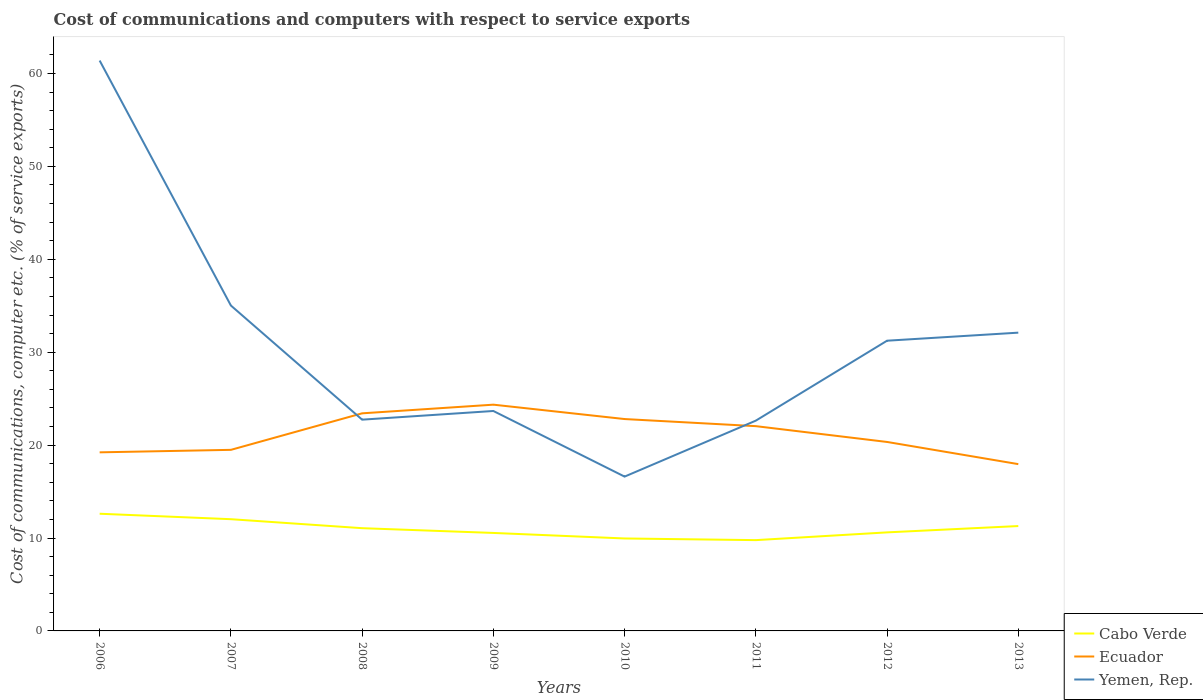Is the number of lines equal to the number of legend labels?
Your answer should be compact. Yes. Across all years, what is the maximum cost of communications and computers in Yemen, Rep.?
Offer a very short reply. 16.61. In which year was the cost of communications and computers in Ecuador maximum?
Offer a very short reply. 2013. What is the total cost of communications and computers in Yemen, Rep. in the graph?
Your answer should be very brief. 38.75. What is the difference between the highest and the second highest cost of communications and computers in Ecuador?
Offer a very short reply. 6.4. What is the difference between the highest and the lowest cost of communications and computers in Cabo Verde?
Provide a short and direct response. 4. How many lines are there?
Offer a very short reply. 3. What is the difference between two consecutive major ticks on the Y-axis?
Ensure brevity in your answer.  10. Are the values on the major ticks of Y-axis written in scientific E-notation?
Provide a short and direct response. No. Does the graph contain any zero values?
Offer a very short reply. No. Where does the legend appear in the graph?
Ensure brevity in your answer.  Bottom right. What is the title of the graph?
Give a very brief answer. Cost of communications and computers with respect to service exports. What is the label or title of the X-axis?
Provide a succinct answer. Years. What is the label or title of the Y-axis?
Your answer should be very brief. Cost of communications, computer etc. (% of service exports). What is the Cost of communications, computer etc. (% of service exports) in Cabo Verde in 2006?
Provide a succinct answer. 12.61. What is the Cost of communications, computer etc. (% of service exports) in Ecuador in 2006?
Give a very brief answer. 19.22. What is the Cost of communications, computer etc. (% of service exports) in Yemen, Rep. in 2006?
Your answer should be compact. 61.39. What is the Cost of communications, computer etc. (% of service exports) in Cabo Verde in 2007?
Provide a short and direct response. 12.02. What is the Cost of communications, computer etc. (% of service exports) of Ecuador in 2007?
Offer a very short reply. 19.49. What is the Cost of communications, computer etc. (% of service exports) in Yemen, Rep. in 2007?
Provide a succinct answer. 35.02. What is the Cost of communications, computer etc. (% of service exports) in Cabo Verde in 2008?
Your answer should be compact. 11.06. What is the Cost of communications, computer etc. (% of service exports) of Ecuador in 2008?
Your response must be concise. 23.42. What is the Cost of communications, computer etc. (% of service exports) of Yemen, Rep. in 2008?
Offer a terse response. 22.74. What is the Cost of communications, computer etc. (% of service exports) of Cabo Verde in 2009?
Ensure brevity in your answer.  10.55. What is the Cost of communications, computer etc. (% of service exports) of Ecuador in 2009?
Provide a succinct answer. 24.35. What is the Cost of communications, computer etc. (% of service exports) of Yemen, Rep. in 2009?
Offer a very short reply. 23.67. What is the Cost of communications, computer etc. (% of service exports) in Cabo Verde in 2010?
Keep it short and to the point. 9.95. What is the Cost of communications, computer etc. (% of service exports) in Ecuador in 2010?
Provide a succinct answer. 22.8. What is the Cost of communications, computer etc. (% of service exports) in Yemen, Rep. in 2010?
Offer a terse response. 16.61. What is the Cost of communications, computer etc. (% of service exports) in Cabo Verde in 2011?
Your answer should be compact. 9.77. What is the Cost of communications, computer etc. (% of service exports) of Ecuador in 2011?
Make the answer very short. 22.04. What is the Cost of communications, computer etc. (% of service exports) in Yemen, Rep. in 2011?
Your response must be concise. 22.63. What is the Cost of communications, computer etc. (% of service exports) in Cabo Verde in 2012?
Your answer should be very brief. 10.61. What is the Cost of communications, computer etc. (% of service exports) in Ecuador in 2012?
Give a very brief answer. 20.34. What is the Cost of communications, computer etc. (% of service exports) of Yemen, Rep. in 2012?
Give a very brief answer. 31.24. What is the Cost of communications, computer etc. (% of service exports) of Cabo Verde in 2013?
Your answer should be compact. 11.29. What is the Cost of communications, computer etc. (% of service exports) in Ecuador in 2013?
Keep it short and to the point. 17.95. What is the Cost of communications, computer etc. (% of service exports) in Yemen, Rep. in 2013?
Ensure brevity in your answer.  32.1. Across all years, what is the maximum Cost of communications, computer etc. (% of service exports) in Cabo Verde?
Ensure brevity in your answer.  12.61. Across all years, what is the maximum Cost of communications, computer etc. (% of service exports) of Ecuador?
Keep it short and to the point. 24.35. Across all years, what is the maximum Cost of communications, computer etc. (% of service exports) of Yemen, Rep.?
Offer a very short reply. 61.39. Across all years, what is the minimum Cost of communications, computer etc. (% of service exports) in Cabo Verde?
Your response must be concise. 9.77. Across all years, what is the minimum Cost of communications, computer etc. (% of service exports) of Ecuador?
Offer a very short reply. 17.95. Across all years, what is the minimum Cost of communications, computer etc. (% of service exports) in Yemen, Rep.?
Give a very brief answer. 16.61. What is the total Cost of communications, computer etc. (% of service exports) in Cabo Verde in the graph?
Your answer should be very brief. 87.86. What is the total Cost of communications, computer etc. (% of service exports) in Ecuador in the graph?
Give a very brief answer. 169.61. What is the total Cost of communications, computer etc. (% of service exports) in Yemen, Rep. in the graph?
Offer a terse response. 245.4. What is the difference between the Cost of communications, computer etc. (% of service exports) in Cabo Verde in 2006 and that in 2007?
Make the answer very short. 0.59. What is the difference between the Cost of communications, computer etc. (% of service exports) in Ecuador in 2006 and that in 2007?
Ensure brevity in your answer.  -0.27. What is the difference between the Cost of communications, computer etc. (% of service exports) in Yemen, Rep. in 2006 and that in 2007?
Keep it short and to the point. 26.37. What is the difference between the Cost of communications, computer etc. (% of service exports) of Cabo Verde in 2006 and that in 2008?
Ensure brevity in your answer.  1.55. What is the difference between the Cost of communications, computer etc. (% of service exports) in Ecuador in 2006 and that in 2008?
Provide a succinct answer. -4.2. What is the difference between the Cost of communications, computer etc. (% of service exports) in Yemen, Rep. in 2006 and that in 2008?
Make the answer very short. 38.65. What is the difference between the Cost of communications, computer etc. (% of service exports) of Cabo Verde in 2006 and that in 2009?
Your answer should be compact. 2.07. What is the difference between the Cost of communications, computer etc. (% of service exports) in Ecuador in 2006 and that in 2009?
Your answer should be compact. -5.13. What is the difference between the Cost of communications, computer etc. (% of service exports) in Yemen, Rep. in 2006 and that in 2009?
Your answer should be compact. 37.72. What is the difference between the Cost of communications, computer etc. (% of service exports) of Cabo Verde in 2006 and that in 2010?
Your answer should be compact. 2.66. What is the difference between the Cost of communications, computer etc. (% of service exports) of Ecuador in 2006 and that in 2010?
Your answer should be very brief. -3.58. What is the difference between the Cost of communications, computer etc. (% of service exports) in Yemen, Rep. in 2006 and that in 2010?
Give a very brief answer. 44.78. What is the difference between the Cost of communications, computer etc. (% of service exports) of Cabo Verde in 2006 and that in 2011?
Provide a succinct answer. 2.84. What is the difference between the Cost of communications, computer etc. (% of service exports) of Ecuador in 2006 and that in 2011?
Your answer should be very brief. -2.82. What is the difference between the Cost of communications, computer etc. (% of service exports) in Yemen, Rep. in 2006 and that in 2011?
Ensure brevity in your answer.  38.75. What is the difference between the Cost of communications, computer etc. (% of service exports) of Cabo Verde in 2006 and that in 2012?
Provide a succinct answer. 2.01. What is the difference between the Cost of communications, computer etc. (% of service exports) of Ecuador in 2006 and that in 2012?
Ensure brevity in your answer.  -1.12. What is the difference between the Cost of communications, computer etc. (% of service exports) in Yemen, Rep. in 2006 and that in 2012?
Keep it short and to the point. 30.15. What is the difference between the Cost of communications, computer etc. (% of service exports) of Cabo Verde in 2006 and that in 2013?
Offer a very short reply. 1.33. What is the difference between the Cost of communications, computer etc. (% of service exports) in Ecuador in 2006 and that in 2013?
Give a very brief answer. 1.27. What is the difference between the Cost of communications, computer etc. (% of service exports) of Yemen, Rep. in 2006 and that in 2013?
Offer a very short reply. 29.29. What is the difference between the Cost of communications, computer etc. (% of service exports) of Cabo Verde in 2007 and that in 2008?
Your response must be concise. 0.97. What is the difference between the Cost of communications, computer etc. (% of service exports) of Ecuador in 2007 and that in 2008?
Your answer should be very brief. -3.93. What is the difference between the Cost of communications, computer etc. (% of service exports) in Yemen, Rep. in 2007 and that in 2008?
Offer a very short reply. 12.28. What is the difference between the Cost of communications, computer etc. (% of service exports) of Cabo Verde in 2007 and that in 2009?
Give a very brief answer. 1.48. What is the difference between the Cost of communications, computer etc. (% of service exports) of Ecuador in 2007 and that in 2009?
Make the answer very short. -4.86. What is the difference between the Cost of communications, computer etc. (% of service exports) of Yemen, Rep. in 2007 and that in 2009?
Ensure brevity in your answer.  11.35. What is the difference between the Cost of communications, computer etc. (% of service exports) in Cabo Verde in 2007 and that in 2010?
Provide a short and direct response. 2.07. What is the difference between the Cost of communications, computer etc. (% of service exports) in Ecuador in 2007 and that in 2010?
Ensure brevity in your answer.  -3.32. What is the difference between the Cost of communications, computer etc. (% of service exports) of Yemen, Rep. in 2007 and that in 2010?
Ensure brevity in your answer.  18.41. What is the difference between the Cost of communications, computer etc. (% of service exports) of Cabo Verde in 2007 and that in 2011?
Your answer should be very brief. 2.25. What is the difference between the Cost of communications, computer etc. (% of service exports) of Ecuador in 2007 and that in 2011?
Keep it short and to the point. -2.55. What is the difference between the Cost of communications, computer etc. (% of service exports) in Yemen, Rep. in 2007 and that in 2011?
Make the answer very short. 12.39. What is the difference between the Cost of communications, computer etc. (% of service exports) in Cabo Verde in 2007 and that in 2012?
Ensure brevity in your answer.  1.42. What is the difference between the Cost of communications, computer etc. (% of service exports) of Ecuador in 2007 and that in 2012?
Make the answer very short. -0.85. What is the difference between the Cost of communications, computer etc. (% of service exports) in Yemen, Rep. in 2007 and that in 2012?
Provide a succinct answer. 3.79. What is the difference between the Cost of communications, computer etc. (% of service exports) in Cabo Verde in 2007 and that in 2013?
Provide a succinct answer. 0.74. What is the difference between the Cost of communications, computer etc. (% of service exports) of Ecuador in 2007 and that in 2013?
Your answer should be very brief. 1.54. What is the difference between the Cost of communications, computer etc. (% of service exports) in Yemen, Rep. in 2007 and that in 2013?
Keep it short and to the point. 2.92. What is the difference between the Cost of communications, computer etc. (% of service exports) of Cabo Verde in 2008 and that in 2009?
Offer a very short reply. 0.51. What is the difference between the Cost of communications, computer etc. (% of service exports) in Ecuador in 2008 and that in 2009?
Offer a terse response. -0.93. What is the difference between the Cost of communications, computer etc. (% of service exports) of Yemen, Rep. in 2008 and that in 2009?
Offer a very short reply. -0.93. What is the difference between the Cost of communications, computer etc. (% of service exports) of Cabo Verde in 2008 and that in 2010?
Keep it short and to the point. 1.11. What is the difference between the Cost of communications, computer etc. (% of service exports) of Ecuador in 2008 and that in 2010?
Your response must be concise. 0.62. What is the difference between the Cost of communications, computer etc. (% of service exports) in Yemen, Rep. in 2008 and that in 2010?
Offer a terse response. 6.13. What is the difference between the Cost of communications, computer etc. (% of service exports) in Cabo Verde in 2008 and that in 2011?
Ensure brevity in your answer.  1.29. What is the difference between the Cost of communications, computer etc. (% of service exports) of Ecuador in 2008 and that in 2011?
Give a very brief answer. 1.38. What is the difference between the Cost of communications, computer etc. (% of service exports) of Yemen, Rep. in 2008 and that in 2011?
Your answer should be very brief. 0.11. What is the difference between the Cost of communications, computer etc. (% of service exports) of Cabo Verde in 2008 and that in 2012?
Your answer should be compact. 0.45. What is the difference between the Cost of communications, computer etc. (% of service exports) of Ecuador in 2008 and that in 2012?
Give a very brief answer. 3.08. What is the difference between the Cost of communications, computer etc. (% of service exports) of Yemen, Rep. in 2008 and that in 2012?
Make the answer very short. -8.5. What is the difference between the Cost of communications, computer etc. (% of service exports) in Cabo Verde in 2008 and that in 2013?
Keep it short and to the point. -0.23. What is the difference between the Cost of communications, computer etc. (% of service exports) of Ecuador in 2008 and that in 2013?
Offer a terse response. 5.47. What is the difference between the Cost of communications, computer etc. (% of service exports) of Yemen, Rep. in 2008 and that in 2013?
Provide a short and direct response. -9.36. What is the difference between the Cost of communications, computer etc. (% of service exports) of Cabo Verde in 2009 and that in 2010?
Offer a terse response. 0.6. What is the difference between the Cost of communications, computer etc. (% of service exports) of Ecuador in 2009 and that in 2010?
Keep it short and to the point. 1.55. What is the difference between the Cost of communications, computer etc. (% of service exports) of Yemen, Rep. in 2009 and that in 2010?
Ensure brevity in your answer.  7.06. What is the difference between the Cost of communications, computer etc. (% of service exports) in Cabo Verde in 2009 and that in 2011?
Offer a terse response. 0.77. What is the difference between the Cost of communications, computer etc. (% of service exports) of Ecuador in 2009 and that in 2011?
Your answer should be very brief. 2.31. What is the difference between the Cost of communications, computer etc. (% of service exports) in Yemen, Rep. in 2009 and that in 2011?
Your answer should be very brief. 1.04. What is the difference between the Cost of communications, computer etc. (% of service exports) of Cabo Verde in 2009 and that in 2012?
Make the answer very short. -0.06. What is the difference between the Cost of communications, computer etc. (% of service exports) of Ecuador in 2009 and that in 2012?
Your response must be concise. 4.01. What is the difference between the Cost of communications, computer etc. (% of service exports) of Yemen, Rep. in 2009 and that in 2012?
Make the answer very short. -7.56. What is the difference between the Cost of communications, computer etc. (% of service exports) in Cabo Verde in 2009 and that in 2013?
Give a very brief answer. -0.74. What is the difference between the Cost of communications, computer etc. (% of service exports) of Ecuador in 2009 and that in 2013?
Your response must be concise. 6.4. What is the difference between the Cost of communications, computer etc. (% of service exports) in Yemen, Rep. in 2009 and that in 2013?
Provide a succinct answer. -8.43. What is the difference between the Cost of communications, computer etc. (% of service exports) of Cabo Verde in 2010 and that in 2011?
Give a very brief answer. 0.18. What is the difference between the Cost of communications, computer etc. (% of service exports) in Ecuador in 2010 and that in 2011?
Your response must be concise. 0.77. What is the difference between the Cost of communications, computer etc. (% of service exports) in Yemen, Rep. in 2010 and that in 2011?
Give a very brief answer. -6.02. What is the difference between the Cost of communications, computer etc. (% of service exports) in Cabo Verde in 2010 and that in 2012?
Offer a very short reply. -0.66. What is the difference between the Cost of communications, computer etc. (% of service exports) of Ecuador in 2010 and that in 2012?
Give a very brief answer. 2.47. What is the difference between the Cost of communications, computer etc. (% of service exports) of Yemen, Rep. in 2010 and that in 2012?
Your answer should be compact. -14.63. What is the difference between the Cost of communications, computer etc. (% of service exports) in Cabo Verde in 2010 and that in 2013?
Offer a very short reply. -1.34. What is the difference between the Cost of communications, computer etc. (% of service exports) of Ecuador in 2010 and that in 2013?
Your answer should be compact. 4.85. What is the difference between the Cost of communications, computer etc. (% of service exports) in Yemen, Rep. in 2010 and that in 2013?
Provide a succinct answer. -15.49. What is the difference between the Cost of communications, computer etc. (% of service exports) of Cabo Verde in 2011 and that in 2012?
Your answer should be compact. -0.83. What is the difference between the Cost of communications, computer etc. (% of service exports) of Ecuador in 2011 and that in 2012?
Offer a very short reply. 1.7. What is the difference between the Cost of communications, computer etc. (% of service exports) in Yemen, Rep. in 2011 and that in 2012?
Your answer should be very brief. -8.6. What is the difference between the Cost of communications, computer etc. (% of service exports) in Cabo Verde in 2011 and that in 2013?
Make the answer very short. -1.52. What is the difference between the Cost of communications, computer etc. (% of service exports) of Ecuador in 2011 and that in 2013?
Make the answer very short. 4.09. What is the difference between the Cost of communications, computer etc. (% of service exports) in Yemen, Rep. in 2011 and that in 2013?
Give a very brief answer. -9.47. What is the difference between the Cost of communications, computer etc. (% of service exports) of Cabo Verde in 2012 and that in 2013?
Provide a short and direct response. -0.68. What is the difference between the Cost of communications, computer etc. (% of service exports) in Ecuador in 2012 and that in 2013?
Give a very brief answer. 2.39. What is the difference between the Cost of communications, computer etc. (% of service exports) in Yemen, Rep. in 2012 and that in 2013?
Offer a very short reply. -0.87. What is the difference between the Cost of communications, computer etc. (% of service exports) of Cabo Verde in 2006 and the Cost of communications, computer etc. (% of service exports) of Ecuador in 2007?
Provide a succinct answer. -6.88. What is the difference between the Cost of communications, computer etc. (% of service exports) of Cabo Verde in 2006 and the Cost of communications, computer etc. (% of service exports) of Yemen, Rep. in 2007?
Offer a terse response. -22.41. What is the difference between the Cost of communications, computer etc. (% of service exports) in Ecuador in 2006 and the Cost of communications, computer etc. (% of service exports) in Yemen, Rep. in 2007?
Your answer should be compact. -15.8. What is the difference between the Cost of communications, computer etc. (% of service exports) in Cabo Verde in 2006 and the Cost of communications, computer etc. (% of service exports) in Ecuador in 2008?
Offer a very short reply. -10.81. What is the difference between the Cost of communications, computer etc. (% of service exports) in Cabo Verde in 2006 and the Cost of communications, computer etc. (% of service exports) in Yemen, Rep. in 2008?
Your answer should be compact. -10.13. What is the difference between the Cost of communications, computer etc. (% of service exports) of Ecuador in 2006 and the Cost of communications, computer etc. (% of service exports) of Yemen, Rep. in 2008?
Give a very brief answer. -3.52. What is the difference between the Cost of communications, computer etc. (% of service exports) in Cabo Verde in 2006 and the Cost of communications, computer etc. (% of service exports) in Ecuador in 2009?
Offer a terse response. -11.74. What is the difference between the Cost of communications, computer etc. (% of service exports) of Cabo Verde in 2006 and the Cost of communications, computer etc. (% of service exports) of Yemen, Rep. in 2009?
Your answer should be very brief. -11.06. What is the difference between the Cost of communications, computer etc. (% of service exports) in Ecuador in 2006 and the Cost of communications, computer etc. (% of service exports) in Yemen, Rep. in 2009?
Ensure brevity in your answer.  -4.45. What is the difference between the Cost of communications, computer etc. (% of service exports) in Cabo Verde in 2006 and the Cost of communications, computer etc. (% of service exports) in Ecuador in 2010?
Provide a short and direct response. -10.19. What is the difference between the Cost of communications, computer etc. (% of service exports) in Cabo Verde in 2006 and the Cost of communications, computer etc. (% of service exports) in Yemen, Rep. in 2010?
Your response must be concise. -4. What is the difference between the Cost of communications, computer etc. (% of service exports) of Ecuador in 2006 and the Cost of communications, computer etc. (% of service exports) of Yemen, Rep. in 2010?
Keep it short and to the point. 2.61. What is the difference between the Cost of communications, computer etc. (% of service exports) of Cabo Verde in 2006 and the Cost of communications, computer etc. (% of service exports) of Ecuador in 2011?
Offer a very short reply. -9.43. What is the difference between the Cost of communications, computer etc. (% of service exports) in Cabo Verde in 2006 and the Cost of communications, computer etc. (% of service exports) in Yemen, Rep. in 2011?
Your response must be concise. -10.02. What is the difference between the Cost of communications, computer etc. (% of service exports) in Ecuador in 2006 and the Cost of communications, computer etc. (% of service exports) in Yemen, Rep. in 2011?
Give a very brief answer. -3.41. What is the difference between the Cost of communications, computer etc. (% of service exports) of Cabo Verde in 2006 and the Cost of communications, computer etc. (% of service exports) of Ecuador in 2012?
Your answer should be very brief. -7.73. What is the difference between the Cost of communications, computer etc. (% of service exports) of Cabo Verde in 2006 and the Cost of communications, computer etc. (% of service exports) of Yemen, Rep. in 2012?
Keep it short and to the point. -18.62. What is the difference between the Cost of communications, computer etc. (% of service exports) of Ecuador in 2006 and the Cost of communications, computer etc. (% of service exports) of Yemen, Rep. in 2012?
Your answer should be compact. -12.02. What is the difference between the Cost of communications, computer etc. (% of service exports) of Cabo Verde in 2006 and the Cost of communications, computer etc. (% of service exports) of Ecuador in 2013?
Your answer should be very brief. -5.34. What is the difference between the Cost of communications, computer etc. (% of service exports) in Cabo Verde in 2006 and the Cost of communications, computer etc. (% of service exports) in Yemen, Rep. in 2013?
Your answer should be very brief. -19.49. What is the difference between the Cost of communications, computer etc. (% of service exports) of Ecuador in 2006 and the Cost of communications, computer etc. (% of service exports) of Yemen, Rep. in 2013?
Your answer should be very brief. -12.88. What is the difference between the Cost of communications, computer etc. (% of service exports) of Cabo Verde in 2007 and the Cost of communications, computer etc. (% of service exports) of Ecuador in 2008?
Offer a terse response. -11.39. What is the difference between the Cost of communications, computer etc. (% of service exports) of Cabo Verde in 2007 and the Cost of communications, computer etc. (% of service exports) of Yemen, Rep. in 2008?
Your answer should be compact. -10.71. What is the difference between the Cost of communications, computer etc. (% of service exports) of Ecuador in 2007 and the Cost of communications, computer etc. (% of service exports) of Yemen, Rep. in 2008?
Provide a succinct answer. -3.25. What is the difference between the Cost of communications, computer etc. (% of service exports) in Cabo Verde in 2007 and the Cost of communications, computer etc. (% of service exports) in Ecuador in 2009?
Provide a short and direct response. -12.33. What is the difference between the Cost of communications, computer etc. (% of service exports) of Cabo Verde in 2007 and the Cost of communications, computer etc. (% of service exports) of Yemen, Rep. in 2009?
Your response must be concise. -11.65. What is the difference between the Cost of communications, computer etc. (% of service exports) of Ecuador in 2007 and the Cost of communications, computer etc. (% of service exports) of Yemen, Rep. in 2009?
Make the answer very short. -4.18. What is the difference between the Cost of communications, computer etc. (% of service exports) in Cabo Verde in 2007 and the Cost of communications, computer etc. (% of service exports) in Ecuador in 2010?
Ensure brevity in your answer.  -10.78. What is the difference between the Cost of communications, computer etc. (% of service exports) in Cabo Verde in 2007 and the Cost of communications, computer etc. (% of service exports) in Yemen, Rep. in 2010?
Your response must be concise. -4.58. What is the difference between the Cost of communications, computer etc. (% of service exports) in Ecuador in 2007 and the Cost of communications, computer etc. (% of service exports) in Yemen, Rep. in 2010?
Keep it short and to the point. 2.88. What is the difference between the Cost of communications, computer etc. (% of service exports) of Cabo Verde in 2007 and the Cost of communications, computer etc. (% of service exports) of Ecuador in 2011?
Keep it short and to the point. -10.01. What is the difference between the Cost of communications, computer etc. (% of service exports) in Cabo Verde in 2007 and the Cost of communications, computer etc. (% of service exports) in Yemen, Rep. in 2011?
Provide a succinct answer. -10.61. What is the difference between the Cost of communications, computer etc. (% of service exports) of Ecuador in 2007 and the Cost of communications, computer etc. (% of service exports) of Yemen, Rep. in 2011?
Offer a very short reply. -3.14. What is the difference between the Cost of communications, computer etc. (% of service exports) of Cabo Verde in 2007 and the Cost of communications, computer etc. (% of service exports) of Ecuador in 2012?
Ensure brevity in your answer.  -8.31. What is the difference between the Cost of communications, computer etc. (% of service exports) in Cabo Verde in 2007 and the Cost of communications, computer etc. (% of service exports) in Yemen, Rep. in 2012?
Make the answer very short. -19.21. What is the difference between the Cost of communications, computer etc. (% of service exports) in Ecuador in 2007 and the Cost of communications, computer etc. (% of service exports) in Yemen, Rep. in 2012?
Give a very brief answer. -11.75. What is the difference between the Cost of communications, computer etc. (% of service exports) in Cabo Verde in 2007 and the Cost of communications, computer etc. (% of service exports) in Ecuador in 2013?
Your response must be concise. -5.93. What is the difference between the Cost of communications, computer etc. (% of service exports) of Cabo Verde in 2007 and the Cost of communications, computer etc. (% of service exports) of Yemen, Rep. in 2013?
Make the answer very short. -20.08. What is the difference between the Cost of communications, computer etc. (% of service exports) in Ecuador in 2007 and the Cost of communications, computer etc. (% of service exports) in Yemen, Rep. in 2013?
Keep it short and to the point. -12.61. What is the difference between the Cost of communications, computer etc. (% of service exports) of Cabo Verde in 2008 and the Cost of communications, computer etc. (% of service exports) of Ecuador in 2009?
Your answer should be compact. -13.29. What is the difference between the Cost of communications, computer etc. (% of service exports) of Cabo Verde in 2008 and the Cost of communications, computer etc. (% of service exports) of Yemen, Rep. in 2009?
Keep it short and to the point. -12.61. What is the difference between the Cost of communications, computer etc. (% of service exports) in Ecuador in 2008 and the Cost of communications, computer etc. (% of service exports) in Yemen, Rep. in 2009?
Give a very brief answer. -0.25. What is the difference between the Cost of communications, computer etc. (% of service exports) in Cabo Verde in 2008 and the Cost of communications, computer etc. (% of service exports) in Ecuador in 2010?
Your answer should be compact. -11.75. What is the difference between the Cost of communications, computer etc. (% of service exports) of Cabo Verde in 2008 and the Cost of communications, computer etc. (% of service exports) of Yemen, Rep. in 2010?
Offer a terse response. -5.55. What is the difference between the Cost of communications, computer etc. (% of service exports) of Ecuador in 2008 and the Cost of communications, computer etc. (% of service exports) of Yemen, Rep. in 2010?
Ensure brevity in your answer.  6.81. What is the difference between the Cost of communications, computer etc. (% of service exports) in Cabo Verde in 2008 and the Cost of communications, computer etc. (% of service exports) in Ecuador in 2011?
Your response must be concise. -10.98. What is the difference between the Cost of communications, computer etc. (% of service exports) in Cabo Verde in 2008 and the Cost of communications, computer etc. (% of service exports) in Yemen, Rep. in 2011?
Provide a succinct answer. -11.57. What is the difference between the Cost of communications, computer etc. (% of service exports) of Ecuador in 2008 and the Cost of communications, computer etc. (% of service exports) of Yemen, Rep. in 2011?
Offer a very short reply. 0.79. What is the difference between the Cost of communications, computer etc. (% of service exports) of Cabo Verde in 2008 and the Cost of communications, computer etc. (% of service exports) of Ecuador in 2012?
Provide a succinct answer. -9.28. What is the difference between the Cost of communications, computer etc. (% of service exports) of Cabo Verde in 2008 and the Cost of communications, computer etc. (% of service exports) of Yemen, Rep. in 2012?
Your answer should be very brief. -20.18. What is the difference between the Cost of communications, computer etc. (% of service exports) of Ecuador in 2008 and the Cost of communications, computer etc. (% of service exports) of Yemen, Rep. in 2012?
Give a very brief answer. -7.82. What is the difference between the Cost of communications, computer etc. (% of service exports) of Cabo Verde in 2008 and the Cost of communications, computer etc. (% of service exports) of Ecuador in 2013?
Keep it short and to the point. -6.89. What is the difference between the Cost of communications, computer etc. (% of service exports) of Cabo Verde in 2008 and the Cost of communications, computer etc. (% of service exports) of Yemen, Rep. in 2013?
Your response must be concise. -21.04. What is the difference between the Cost of communications, computer etc. (% of service exports) of Ecuador in 2008 and the Cost of communications, computer etc. (% of service exports) of Yemen, Rep. in 2013?
Your answer should be very brief. -8.68. What is the difference between the Cost of communications, computer etc. (% of service exports) of Cabo Verde in 2009 and the Cost of communications, computer etc. (% of service exports) of Ecuador in 2010?
Keep it short and to the point. -12.26. What is the difference between the Cost of communications, computer etc. (% of service exports) of Cabo Verde in 2009 and the Cost of communications, computer etc. (% of service exports) of Yemen, Rep. in 2010?
Provide a succinct answer. -6.06. What is the difference between the Cost of communications, computer etc. (% of service exports) in Ecuador in 2009 and the Cost of communications, computer etc. (% of service exports) in Yemen, Rep. in 2010?
Your answer should be very brief. 7.74. What is the difference between the Cost of communications, computer etc. (% of service exports) in Cabo Verde in 2009 and the Cost of communications, computer etc. (% of service exports) in Ecuador in 2011?
Your answer should be very brief. -11.49. What is the difference between the Cost of communications, computer etc. (% of service exports) in Cabo Verde in 2009 and the Cost of communications, computer etc. (% of service exports) in Yemen, Rep. in 2011?
Ensure brevity in your answer.  -12.09. What is the difference between the Cost of communications, computer etc. (% of service exports) of Ecuador in 2009 and the Cost of communications, computer etc. (% of service exports) of Yemen, Rep. in 2011?
Provide a succinct answer. 1.72. What is the difference between the Cost of communications, computer etc. (% of service exports) in Cabo Verde in 2009 and the Cost of communications, computer etc. (% of service exports) in Ecuador in 2012?
Your answer should be compact. -9.79. What is the difference between the Cost of communications, computer etc. (% of service exports) in Cabo Verde in 2009 and the Cost of communications, computer etc. (% of service exports) in Yemen, Rep. in 2012?
Offer a terse response. -20.69. What is the difference between the Cost of communications, computer etc. (% of service exports) of Ecuador in 2009 and the Cost of communications, computer etc. (% of service exports) of Yemen, Rep. in 2012?
Your answer should be compact. -6.88. What is the difference between the Cost of communications, computer etc. (% of service exports) of Cabo Verde in 2009 and the Cost of communications, computer etc. (% of service exports) of Ecuador in 2013?
Offer a terse response. -7.41. What is the difference between the Cost of communications, computer etc. (% of service exports) in Cabo Verde in 2009 and the Cost of communications, computer etc. (% of service exports) in Yemen, Rep. in 2013?
Offer a very short reply. -21.56. What is the difference between the Cost of communications, computer etc. (% of service exports) in Ecuador in 2009 and the Cost of communications, computer etc. (% of service exports) in Yemen, Rep. in 2013?
Your response must be concise. -7.75. What is the difference between the Cost of communications, computer etc. (% of service exports) in Cabo Verde in 2010 and the Cost of communications, computer etc. (% of service exports) in Ecuador in 2011?
Give a very brief answer. -12.09. What is the difference between the Cost of communications, computer etc. (% of service exports) in Cabo Verde in 2010 and the Cost of communications, computer etc. (% of service exports) in Yemen, Rep. in 2011?
Provide a succinct answer. -12.68. What is the difference between the Cost of communications, computer etc. (% of service exports) of Ecuador in 2010 and the Cost of communications, computer etc. (% of service exports) of Yemen, Rep. in 2011?
Keep it short and to the point. 0.17. What is the difference between the Cost of communications, computer etc. (% of service exports) in Cabo Verde in 2010 and the Cost of communications, computer etc. (% of service exports) in Ecuador in 2012?
Ensure brevity in your answer.  -10.39. What is the difference between the Cost of communications, computer etc. (% of service exports) of Cabo Verde in 2010 and the Cost of communications, computer etc. (% of service exports) of Yemen, Rep. in 2012?
Your answer should be compact. -21.29. What is the difference between the Cost of communications, computer etc. (% of service exports) in Ecuador in 2010 and the Cost of communications, computer etc. (% of service exports) in Yemen, Rep. in 2012?
Provide a short and direct response. -8.43. What is the difference between the Cost of communications, computer etc. (% of service exports) of Cabo Verde in 2010 and the Cost of communications, computer etc. (% of service exports) of Ecuador in 2013?
Ensure brevity in your answer.  -8. What is the difference between the Cost of communications, computer etc. (% of service exports) of Cabo Verde in 2010 and the Cost of communications, computer etc. (% of service exports) of Yemen, Rep. in 2013?
Your answer should be very brief. -22.15. What is the difference between the Cost of communications, computer etc. (% of service exports) in Ecuador in 2010 and the Cost of communications, computer etc. (% of service exports) in Yemen, Rep. in 2013?
Offer a terse response. -9.3. What is the difference between the Cost of communications, computer etc. (% of service exports) in Cabo Verde in 2011 and the Cost of communications, computer etc. (% of service exports) in Ecuador in 2012?
Your answer should be very brief. -10.57. What is the difference between the Cost of communications, computer etc. (% of service exports) in Cabo Verde in 2011 and the Cost of communications, computer etc. (% of service exports) in Yemen, Rep. in 2012?
Keep it short and to the point. -21.46. What is the difference between the Cost of communications, computer etc. (% of service exports) of Ecuador in 2011 and the Cost of communications, computer etc. (% of service exports) of Yemen, Rep. in 2012?
Your answer should be compact. -9.2. What is the difference between the Cost of communications, computer etc. (% of service exports) of Cabo Verde in 2011 and the Cost of communications, computer etc. (% of service exports) of Ecuador in 2013?
Provide a short and direct response. -8.18. What is the difference between the Cost of communications, computer etc. (% of service exports) of Cabo Verde in 2011 and the Cost of communications, computer etc. (% of service exports) of Yemen, Rep. in 2013?
Ensure brevity in your answer.  -22.33. What is the difference between the Cost of communications, computer etc. (% of service exports) of Ecuador in 2011 and the Cost of communications, computer etc. (% of service exports) of Yemen, Rep. in 2013?
Keep it short and to the point. -10.06. What is the difference between the Cost of communications, computer etc. (% of service exports) of Cabo Verde in 2012 and the Cost of communications, computer etc. (% of service exports) of Ecuador in 2013?
Ensure brevity in your answer.  -7.34. What is the difference between the Cost of communications, computer etc. (% of service exports) of Cabo Verde in 2012 and the Cost of communications, computer etc. (% of service exports) of Yemen, Rep. in 2013?
Your answer should be very brief. -21.5. What is the difference between the Cost of communications, computer etc. (% of service exports) of Ecuador in 2012 and the Cost of communications, computer etc. (% of service exports) of Yemen, Rep. in 2013?
Offer a very short reply. -11.76. What is the average Cost of communications, computer etc. (% of service exports) in Cabo Verde per year?
Provide a short and direct response. 10.98. What is the average Cost of communications, computer etc. (% of service exports) in Ecuador per year?
Offer a terse response. 21.2. What is the average Cost of communications, computer etc. (% of service exports) of Yemen, Rep. per year?
Give a very brief answer. 30.68. In the year 2006, what is the difference between the Cost of communications, computer etc. (% of service exports) in Cabo Verde and Cost of communications, computer etc. (% of service exports) in Ecuador?
Your answer should be compact. -6.61. In the year 2006, what is the difference between the Cost of communications, computer etc. (% of service exports) of Cabo Verde and Cost of communications, computer etc. (% of service exports) of Yemen, Rep.?
Your response must be concise. -48.78. In the year 2006, what is the difference between the Cost of communications, computer etc. (% of service exports) in Ecuador and Cost of communications, computer etc. (% of service exports) in Yemen, Rep.?
Offer a very short reply. -42.17. In the year 2007, what is the difference between the Cost of communications, computer etc. (% of service exports) in Cabo Verde and Cost of communications, computer etc. (% of service exports) in Ecuador?
Provide a succinct answer. -7.46. In the year 2007, what is the difference between the Cost of communications, computer etc. (% of service exports) in Cabo Verde and Cost of communications, computer etc. (% of service exports) in Yemen, Rep.?
Your response must be concise. -23. In the year 2007, what is the difference between the Cost of communications, computer etc. (% of service exports) in Ecuador and Cost of communications, computer etc. (% of service exports) in Yemen, Rep.?
Provide a succinct answer. -15.53. In the year 2008, what is the difference between the Cost of communications, computer etc. (% of service exports) in Cabo Verde and Cost of communications, computer etc. (% of service exports) in Ecuador?
Keep it short and to the point. -12.36. In the year 2008, what is the difference between the Cost of communications, computer etc. (% of service exports) of Cabo Verde and Cost of communications, computer etc. (% of service exports) of Yemen, Rep.?
Offer a terse response. -11.68. In the year 2008, what is the difference between the Cost of communications, computer etc. (% of service exports) in Ecuador and Cost of communications, computer etc. (% of service exports) in Yemen, Rep.?
Ensure brevity in your answer.  0.68. In the year 2009, what is the difference between the Cost of communications, computer etc. (% of service exports) in Cabo Verde and Cost of communications, computer etc. (% of service exports) in Ecuador?
Offer a very short reply. -13.81. In the year 2009, what is the difference between the Cost of communications, computer etc. (% of service exports) of Cabo Verde and Cost of communications, computer etc. (% of service exports) of Yemen, Rep.?
Your answer should be very brief. -13.13. In the year 2009, what is the difference between the Cost of communications, computer etc. (% of service exports) in Ecuador and Cost of communications, computer etc. (% of service exports) in Yemen, Rep.?
Offer a terse response. 0.68. In the year 2010, what is the difference between the Cost of communications, computer etc. (% of service exports) in Cabo Verde and Cost of communications, computer etc. (% of service exports) in Ecuador?
Your response must be concise. -12.85. In the year 2010, what is the difference between the Cost of communications, computer etc. (% of service exports) of Cabo Verde and Cost of communications, computer etc. (% of service exports) of Yemen, Rep.?
Provide a succinct answer. -6.66. In the year 2010, what is the difference between the Cost of communications, computer etc. (% of service exports) in Ecuador and Cost of communications, computer etc. (% of service exports) in Yemen, Rep.?
Offer a very short reply. 6.19. In the year 2011, what is the difference between the Cost of communications, computer etc. (% of service exports) of Cabo Verde and Cost of communications, computer etc. (% of service exports) of Ecuador?
Offer a very short reply. -12.27. In the year 2011, what is the difference between the Cost of communications, computer etc. (% of service exports) in Cabo Verde and Cost of communications, computer etc. (% of service exports) in Yemen, Rep.?
Provide a short and direct response. -12.86. In the year 2011, what is the difference between the Cost of communications, computer etc. (% of service exports) of Ecuador and Cost of communications, computer etc. (% of service exports) of Yemen, Rep.?
Keep it short and to the point. -0.59. In the year 2012, what is the difference between the Cost of communications, computer etc. (% of service exports) of Cabo Verde and Cost of communications, computer etc. (% of service exports) of Ecuador?
Give a very brief answer. -9.73. In the year 2012, what is the difference between the Cost of communications, computer etc. (% of service exports) of Cabo Verde and Cost of communications, computer etc. (% of service exports) of Yemen, Rep.?
Keep it short and to the point. -20.63. In the year 2012, what is the difference between the Cost of communications, computer etc. (% of service exports) in Ecuador and Cost of communications, computer etc. (% of service exports) in Yemen, Rep.?
Offer a terse response. -10.9. In the year 2013, what is the difference between the Cost of communications, computer etc. (% of service exports) of Cabo Verde and Cost of communications, computer etc. (% of service exports) of Ecuador?
Offer a terse response. -6.66. In the year 2013, what is the difference between the Cost of communications, computer etc. (% of service exports) of Cabo Verde and Cost of communications, computer etc. (% of service exports) of Yemen, Rep.?
Your answer should be compact. -20.81. In the year 2013, what is the difference between the Cost of communications, computer etc. (% of service exports) in Ecuador and Cost of communications, computer etc. (% of service exports) in Yemen, Rep.?
Offer a terse response. -14.15. What is the ratio of the Cost of communications, computer etc. (% of service exports) of Cabo Verde in 2006 to that in 2007?
Give a very brief answer. 1.05. What is the ratio of the Cost of communications, computer etc. (% of service exports) of Ecuador in 2006 to that in 2007?
Offer a terse response. 0.99. What is the ratio of the Cost of communications, computer etc. (% of service exports) of Yemen, Rep. in 2006 to that in 2007?
Ensure brevity in your answer.  1.75. What is the ratio of the Cost of communications, computer etc. (% of service exports) of Cabo Verde in 2006 to that in 2008?
Offer a terse response. 1.14. What is the ratio of the Cost of communications, computer etc. (% of service exports) in Ecuador in 2006 to that in 2008?
Provide a succinct answer. 0.82. What is the ratio of the Cost of communications, computer etc. (% of service exports) of Yemen, Rep. in 2006 to that in 2008?
Make the answer very short. 2.7. What is the ratio of the Cost of communications, computer etc. (% of service exports) of Cabo Verde in 2006 to that in 2009?
Provide a short and direct response. 1.2. What is the ratio of the Cost of communications, computer etc. (% of service exports) of Ecuador in 2006 to that in 2009?
Your answer should be compact. 0.79. What is the ratio of the Cost of communications, computer etc. (% of service exports) in Yemen, Rep. in 2006 to that in 2009?
Make the answer very short. 2.59. What is the ratio of the Cost of communications, computer etc. (% of service exports) in Cabo Verde in 2006 to that in 2010?
Keep it short and to the point. 1.27. What is the ratio of the Cost of communications, computer etc. (% of service exports) of Ecuador in 2006 to that in 2010?
Your response must be concise. 0.84. What is the ratio of the Cost of communications, computer etc. (% of service exports) in Yemen, Rep. in 2006 to that in 2010?
Offer a terse response. 3.7. What is the ratio of the Cost of communications, computer etc. (% of service exports) of Cabo Verde in 2006 to that in 2011?
Make the answer very short. 1.29. What is the ratio of the Cost of communications, computer etc. (% of service exports) in Ecuador in 2006 to that in 2011?
Provide a short and direct response. 0.87. What is the ratio of the Cost of communications, computer etc. (% of service exports) of Yemen, Rep. in 2006 to that in 2011?
Make the answer very short. 2.71. What is the ratio of the Cost of communications, computer etc. (% of service exports) in Cabo Verde in 2006 to that in 2012?
Your response must be concise. 1.19. What is the ratio of the Cost of communications, computer etc. (% of service exports) in Ecuador in 2006 to that in 2012?
Your answer should be very brief. 0.95. What is the ratio of the Cost of communications, computer etc. (% of service exports) of Yemen, Rep. in 2006 to that in 2012?
Your answer should be compact. 1.97. What is the ratio of the Cost of communications, computer etc. (% of service exports) in Cabo Verde in 2006 to that in 2013?
Offer a terse response. 1.12. What is the ratio of the Cost of communications, computer etc. (% of service exports) of Ecuador in 2006 to that in 2013?
Make the answer very short. 1.07. What is the ratio of the Cost of communications, computer etc. (% of service exports) of Yemen, Rep. in 2006 to that in 2013?
Give a very brief answer. 1.91. What is the ratio of the Cost of communications, computer etc. (% of service exports) in Cabo Verde in 2007 to that in 2008?
Give a very brief answer. 1.09. What is the ratio of the Cost of communications, computer etc. (% of service exports) in Ecuador in 2007 to that in 2008?
Give a very brief answer. 0.83. What is the ratio of the Cost of communications, computer etc. (% of service exports) of Yemen, Rep. in 2007 to that in 2008?
Provide a short and direct response. 1.54. What is the ratio of the Cost of communications, computer etc. (% of service exports) of Cabo Verde in 2007 to that in 2009?
Provide a short and direct response. 1.14. What is the ratio of the Cost of communications, computer etc. (% of service exports) in Ecuador in 2007 to that in 2009?
Your answer should be compact. 0.8. What is the ratio of the Cost of communications, computer etc. (% of service exports) in Yemen, Rep. in 2007 to that in 2009?
Your answer should be compact. 1.48. What is the ratio of the Cost of communications, computer etc. (% of service exports) in Cabo Verde in 2007 to that in 2010?
Your response must be concise. 1.21. What is the ratio of the Cost of communications, computer etc. (% of service exports) in Ecuador in 2007 to that in 2010?
Provide a succinct answer. 0.85. What is the ratio of the Cost of communications, computer etc. (% of service exports) in Yemen, Rep. in 2007 to that in 2010?
Your answer should be compact. 2.11. What is the ratio of the Cost of communications, computer etc. (% of service exports) in Cabo Verde in 2007 to that in 2011?
Make the answer very short. 1.23. What is the ratio of the Cost of communications, computer etc. (% of service exports) in Ecuador in 2007 to that in 2011?
Provide a succinct answer. 0.88. What is the ratio of the Cost of communications, computer etc. (% of service exports) of Yemen, Rep. in 2007 to that in 2011?
Your answer should be compact. 1.55. What is the ratio of the Cost of communications, computer etc. (% of service exports) in Cabo Verde in 2007 to that in 2012?
Offer a terse response. 1.13. What is the ratio of the Cost of communications, computer etc. (% of service exports) in Ecuador in 2007 to that in 2012?
Your answer should be compact. 0.96. What is the ratio of the Cost of communications, computer etc. (% of service exports) in Yemen, Rep. in 2007 to that in 2012?
Ensure brevity in your answer.  1.12. What is the ratio of the Cost of communications, computer etc. (% of service exports) in Cabo Verde in 2007 to that in 2013?
Ensure brevity in your answer.  1.07. What is the ratio of the Cost of communications, computer etc. (% of service exports) of Ecuador in 2007 to that in 2013?
Make the answer very short. 1.09. What is the ratio of the Cost of communications, computer etc. (% of service exports) of Yemen, Rep. in 2007 to that in 2013?
Offer a terse response. 1.09. What is the ratio of the Cost of communications, computer etc. (% of service exports) in Cabo Verde in 2008 to that in 2009?
Offer a very short reply. 1.05. What is the ratio of the Cost of communications, computer etc. (% of service exports) of Ecuador in 2008 to that in 2009?
Offer a terse response. 0.96. What is the ratio of the Cost of communications, computer etc. (% of service exports) in Yemen, Rep. in 2008 to that in 2009?
Provide a succinct answer. 0.96. What is the ratio of the Cost of communications, computer etc. (% of service exports) of Cabo Verde in 2008 to that in 2010?
Keep it short and to the point. 1.11. What is the ratio of the Cost of communications, computer etc. (% of service exports) in Ecuador in 2008 to that in 2010?
Keep it short and to the point. 1.03. What is the ratio of the Cost of communications, computer etc. (% of service exports) in Yemen, Rep. in 2008 to that in 2010?
Offer a terse response. 1.37. What is the ratio of the Cost of communications, computer etc. (% of service exports) in Cabo Verde in 2008 to that in 2011?
Provide a short and direct response. 1.13. What is the ratio of the Cost of communications, computer etc. (% of service exports) in Ecuador in 2008 to that in 2011?
Give a very brief answer. 1.06. What is the ratio of the Cost of communications, computer etc. (% of service exports) of Yemen, Rep. in 2008 to that in 2011?
Your answer should be very brief. 1. What is the ratio of the Cost of communications, computer etc. (% of service exports) of Cabo Verde in 2008 to that in 2012?
Ensure brevity in your answer.  1.04. What is the ratio of the Cost of communications, computer etc. (% of service exports) in Ecuador in 2008 to that in 2012?
Your answer should be compact. 1.15. What is the ratio of the Cost of communications, computer etc. (% of service exports) in Yemen, Rep. in 2008 to that in 2012?
Ensure brevity in your answer.  0.73. What is the ratio of the Cost of communications, computer etc. (% of service exports) in Cabo Verde in 2008 to that in 2013?
Offer a very short reply. 0.98. What is the ratio of the Cost of communications, computer etc. (% of service exports) of Ecuador in 2008 to that in 2013?
Make the answer very short. 1.3. What is the ratio of the Cost of communications, computer etc. (% of service exports) of Yemen, Rep. in 2008 to that in 2013?
Give a very brief answer. 0.71. What is the ratio of the Cost of communications, computer etc. (% of service exports) of Cabo Verde in 2009 to that in 2010?
Your response must be concise. 1.06. What is the ratio of the Cost of communications, computer etc. (% of service exports) of Ecuador in 2009 to that in 2010?
Provide a succinct answer. 1.07. What is the ratio of the Cost of communications, computer etc. (% of service exports) of Yemen, Rep. in 2009 to that in 2010?
Your answer should be very brief. 1.43. What is the ratio of the Cost of communications, computer etc. (% of service exports) of Cabo Verde in 2009 to that in 2011?
Offer a very short reply. 1.08. What is the ratio of the Cost of communications, computer etc. (% of service exports) of Ecuador in 2009 to that in 2011?
Provide a succinct answer. 1.1. What is the ratio of the Cost of communications, computer etc. (% of service exports) of Yemen, Rep. in 2009 to that in 2011?
Offer a very short reply. 1.05. What is the ratio of the Cost of communications, computer etc. (% of service exports) of Ecuador in 2009 to that in 2012?
Make the answer very short. 1.2. What is the ratio of the Cost of communications, computer etc. (% of service exports) in Yemen, Rep. in 2009 to that in 2012?
Give a very brief answer. 0.76. What is the ratio of the Cost of communications, computer etc. (% of service exports) of Cabo Verde in 2009 to that in 2013?
Give a very brief answer. 0.93. What is the ratio of the Cost of communications, computer etc. (% of service exports) in Ecuador in 2009 to that in 2013?
Make the answer very short. 1.36. What is the ratio of the Cost of communications, computer etc. (% of service exports) in Yemen, Rep. in 2009 to that in 2013?
Ensure brevity in your answer.  0.74. What is the ratio of the Cost of communications, computer etc. (% of service exports) in Cabo Verde in 2010 to that in 2011?
Provide a short and direct response. 1.02. What is the ratio of the Cost of communications, computer etc. (% of service exports) of Ecuador in 2010 to that in 2011?
Ensure brevity in your answer.  1.03. What is the ratio of the Cost of communications, computer etc. (% of service exports) in Yemen, Rep. in 2010 to that in 2011?
Provide a short and direct response. 0.73. What is the ratio of the Cost of communications, computer etc. (% of service exports) in Cabo Verde in 2010 to that in 2012?
Keep it short and to the point. 0.94. What is the ratio of the Cost of communications, computer etc. (% of service exports) of Ecuador in 2010 to that in 2012?
Make the answer very short. 1.12. What is the ratio of the Cost of communications, computer etc. (% of service exports) of Yemen, Rep. in 2010 to that in 2012?
Your answer should be very brief. 0.53. What is the ratio of the Cost of communications, computer etc. (% of service exports) of Cabo Verde in 2010 to that in 2013?
Your answer should be very brief. 0.88. What is the ratio of the Cost of communications, computer etc. (% of service exports) of Ecuador in 2010 to that in 2013?
Ensure brevity in your answer.  1.27. What is the ratio of the Cost of communications, computer etc. (% of service exports) of Yemen, Rep. in 2010 to that in 2013?
Keep it short and to the point. 0.52. What is the ratio of the Cost of communications, computer etc. (% of service exports) in Cabo Verde in 2011 to that in 2012?
Offer a terse response. 0.92. What is the ratio of the Cost of communications, computer etc. (% of service exports) in Ecuador in 2011 to that in 2012?
Make the answer very short. 1.08. What is the ratio of the Cost of communications, computer etc. (% of service exports) of Yemen, Rep. in 2011 to that in 2012?
Your answer should be compact. 0.72. What is the ratio of the Cost of communications, computer etc. (% of service exports) of Cabo Verde in 2011 to that in 2013?
Provide a succinct answer. 0.87. What is the ratio of the Cost of communications, computer etc. (% of service exports) in Ecuador in 2011 to that in 2013?
Make the answer very short. 1.23. What is the ratio of the Cost of communications, computer etc. (% of service exports) of Yemen, Rep. in 2011 to that in 2013?
Offer a terse response. 0.7. What is the ratio of the Cost of communications, computer etc. (% of service exports) of Cabo Verde in 2012 to that in 2013?
Give a very brief answer. 0.94. What is the ratio of the Cost of communications, computer etc. (% of service exports) of Ecuador in 2012 to that in 2013?
Your answer should be compact. 1.13. What is the ratio of the Cost of communications, computer etc. (% of service exports) in Yemen, Rep. in 2012 to that in 2013?
Provide a succinct answer. 0.97. What is the difference between the highest and the second highest Cost of communications, computer etc. (% of service exports) of Cabo Verde?
Provide a short and direct response. 0.59. What is the difference between the highest and the second highest Cost of communications, computer etc. (% of service exports) in Ecuador?
Give a very brief answer. 0.93. What is the difference between the highest and the second highest Cost of communications, computer etc. (% of service exports) of Yemen, Rep.?
Provide a succinct answer. 26.37. What is the difference between the highest and the lowest Cost of communications, computer etc. (% of service exports) in Cabo Verde?
Offer a very short reply. 2.84. What is the difference between the highest and the lowest Cost of communications, computer etc. (% of service exports) of Ecuador?
Your answer should be very brief. 6.4. What is the difference between the highest and the lowest Cost of communications, computer etc. (% of service exports) in Yemen, Rep.?
Keep it short and to the point. 44.78. 